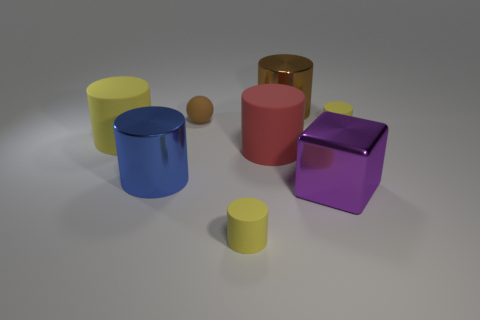What number of things are tiny cyan things or small matte cylinders?
Make the answer very short. 2. What shape is the red thing that is the same size as the purple shiny thing?
Offer a very short reply. Cylinder. How many cylinders are left of the large brown metallic cylinder and right of the ball?
Ensure brevity in your answer.  2. There is a tiny brown object to the left of the big cube; what is it made of?
Give a very brief answer. Rubber. There is a purple block that is made of the same material as the blue cylinder; what size is it?
Provide a succinct answer. Large. Do the cylinder to the right of the purple metal object and the cylinder in front of the blue cylinder have the same size?
Make the answer very short. Yes. There is a yellow object that is the same size as the blue cylinder; what is its material?
Ensure brevity in your answer.  Rubber. What is the yellow object that is both on the right side of the brown rubber ball and on the left side of the large purple shiny block made of?
Your answer should be compact. Rubber. Is there a small brown rubber object?
Make the answer very short. Yes. Is the color of the metal block the same as the large rubber object that is to the left of the blue cylinder?
Provide a succinct answer. No. 